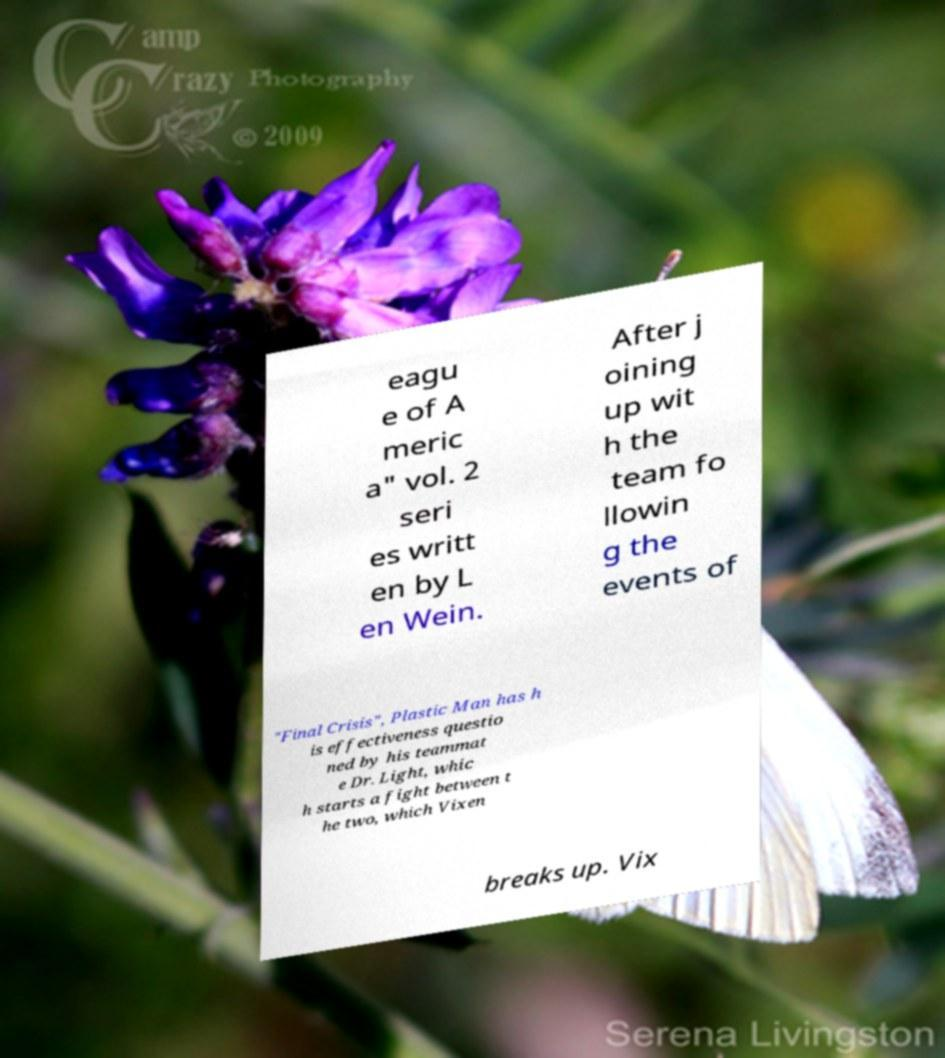Could you extract and type out the text from this image? eagu e of A meric a" vol. 2 seri es writt en by L en Wein. After j oining up wit h the team fo llowin g the events of "Final Crisis", Plastic Man has h is effectiveness questio ned by his teammat e Dr. Light, whic h starts a fight between t he two, which Vixen breaks up. Vix 